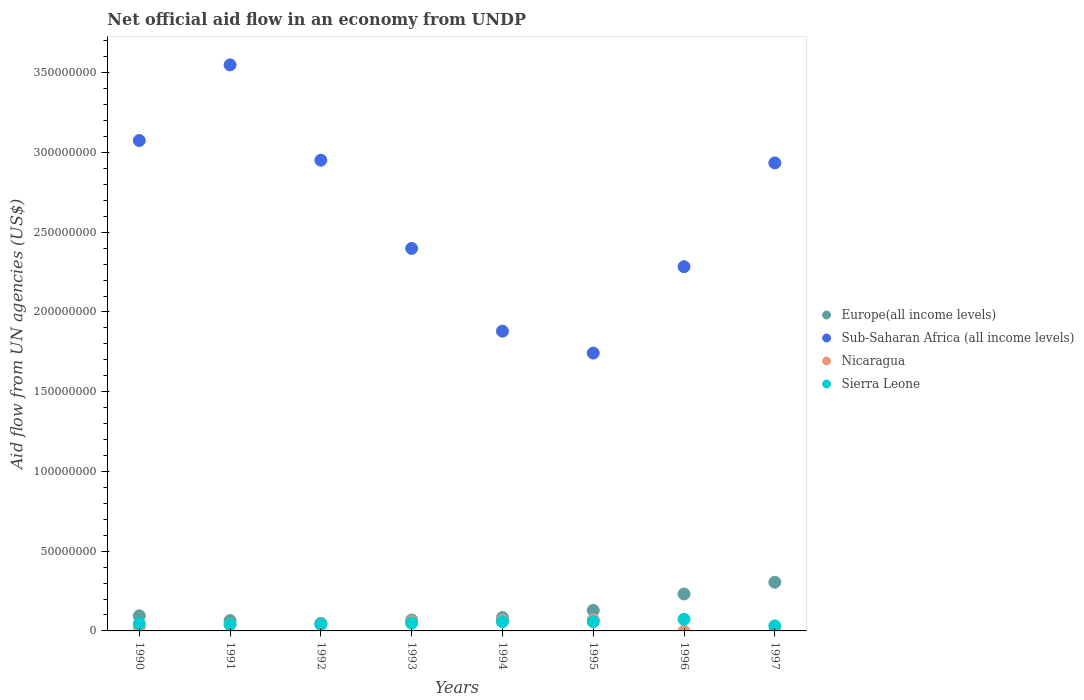Is the number of dotlines equal to the number of legend labels?
Keep it short and to the point. No. What is the net official aid flow in Europe(all income levels) in 1993?
Offer a very short reply. 6.83e+06. Across all years, what is the maximum net official aid flow in Sub-Saharan Africa (all income levels)?
Make the answer very short. 3.55e+08. Across all years, what is the minimum net official aid flow in Europe(all income levels)?
Make the answer very short. 4.74e+06. What is the total net official aid flow in Nicaragua in the graph?
Ensure brevity in your answer.  3.03e+07. What is the difference between the net official aid flow in Sub-Saharan Africa (all income levels) in 1990 and that in 1996?
Provide a short and direct response. 7.91e+07. What is the difference between the net official aid flow in Nicaragua in 1992 and the net official aid flow in Sub-Saharan Africa (all income levels) in 1990?
Keep it short and to the point. -3.03e+08. What is the average net official aid flow in Europe(all income levels) per year?
Offer a very short reply. 1.28e+07. In the year 1993, what is the difference between the net official aid flow in Europe(all income levels) and net official aid flow in Nicaragua?
Provide a succinct answer. 1.08e+06. In how many years, is the net official aid flow in Europe(all income levels) greater than 290000000 US$?
Ensure brevity in your answer.  0. What is the ratio of the net official aid flow in Nicaragua in 1990 to that in 1995?
Your answer should be very brief. 0.33. Is the net official aid flow in Sierra Leone in 1994 less than that in 1996?
Your answer should be compact. Yes. Is the difference between the net official aid flow in Europe(all income levels) in 1991 and 1993 greater than the difference between the net official aid flow in Nicaragua in 1991 and 1993?
Offer a terse response. Yes. What is the difference between the highest and the second highest net official aid flow in Sub-Saharan Africa (all income levels)?
Make the answer very short. 4.74e+07. What is the difference between the highest and the lowest net official aid flow in Sub-Saharan Africa (all income levels)?
Provide a succinct answer. 1.81e+08. Is it the case that in every year, the sum of the net official aid flow in Nicaragua and net official aid flow in Sierra Leone  is greater than the net official aid flow in Europe(all income levels)?
Your answer should be very brief. No. Is the net official aid flow in Sierra Leone strictly less than the net official aid flow in Europe(all income levels) over the years?
Ensure brevity in your answer.  Yes. How many years are there in the graph?
Provide a short and direct response. 8. How many legend labels are there?
Offer a very short reply. 4. What is the title of the graph?
Your answer should be compact. Net official aid flow in an economy from UNDP. Does "Egypt, Arab Rep." appear as one of the legend labels in the graph?
Ensure brevity in your answer.  No. What is the label or title of the Y-axis?
Your answer should be very brief. Aid flow from UN agencies (US$). What is the Aid flow from UN agencies (US$) in Europe(all income levels) in 1990?
Give a very brief answer. 9.47e+06. What is the Aid flow from UN agencies (US$) in Sub-Saharan Africa (all income levels) in 1990?
Give a very brief answer. 3.08e+08. What is the Aid flow from UN agencies (US$) in Nicaragua in 1990?
Your answer should be compact. 2.34e+06. What is the Aid flow from UN agencies (US$) in Sierra Leone in 1990?
Ensure brevity in your answer.  4.57e+06. What is the Aid flow from UN agencies (US$) of Europe(all income levels) in 1991?
Make the answer very short. 6.49e+06. What is the Aid flow from UN agencies (US$) of Sub-Saharan Africa (all income levels) in 1991?
Provide a short and direct response. 3.55e+08. What is the Aid flow from UN agencies (US$) in Nicaragua in 1991?
Provide a succinct answer. 4.14e+06. What is the Aid flow from UN agencies (US$) in Sierra Leone in 1991?
Make the answer very short. 4.04e+06. What is the Aid flow from UN agencies (US$) in Europe(all income levels) in 1992?
Provide a short and direct response. 4.74e+06. What is the Aid flow from UN agencies (US$) in Sub-Saharan Africa (all income levels) in 1992?
Offer a terse response. 2.95e+08. What is the Aid flow from UN agencies (US$) of Nicaragua in 1992?
Your answer should be very brief. 4.34e+06. What is the Aid flow from UN agencies (US$) of Sierra Leone in 1992?
Provide a short and direct response. 4.11e+06. What is the Aid flow from UN agencies (US$) in Europe(all income levels) in 1993?
Make the answer very short. 6.83e+06. What is the Aid flow from UN agencies (US$) of Sub-Saharan Africa (all income levels) in 1993?
Offer a very short reply. 2.40e+08. What is the Aid flow from UN agencies (US$) of Nicaragua in 1993?
Make the answer very short. 5.75e+06. What is the Aid flow from UN agencies (US$) of Sierra Leone in 1993?
Offer a very short reply. 4.93e+06. What is the Aid flow from UN agencies (US$) of Europe(all income levels) in 1994?
Make the answer very short. 8.38e+06. What is the Aid flow from UN agencies (US$) of Sub-Saharan Africa (all income levels) in 1994?
Ensure brevity in your answer.  1.88e+08. What is the Aid flow from UN agencies (US$) in Nicaragua in 1994?
Offer a terse response. 6.73e+06. What is the Aid flow from UN agencies (US$) in Sierra Leone in 1994?
Give a very brief answer. 5.75e+06. What is the Aid flow from UN agencies (US$) in Europe(all income levels) in 1995?
Give a very brief answer. 1.29e+07. What is the Aid flow from UN agencies (US$) in Sub-Saharan Africa (all income levels) in 1995?
Keep it short and to the point. 1.74e+08. What is the Aid flow from UN agencies (US$) of Nicaragua in 1995?
Offer a terse response. 7.02e+06. What is the Aid flow from UN agencies (US$) of Sierra Leone in 1995?
Keep it short and to the point. 5.78e+06. What is the Aid flow from UN agencies (US$) in Europe(all income levels) in 1996?
Your answer should be very brief. 2.32e+07. What is the Aid flow from UN agencies (US$) of Sub-Saharan Africa (all income levels) in 1996?
Offer a very short reply. 2.28e+08. What is the Aid flow from UN agencies (US$) of Sierra Leone in 1996?
Offer a very short reply. 7.28e+06. What is the Aid flow from UN agencies (US$) of Europe(all income levels) in 1997?
Your response must be concise. 3.05e+07. What is the Aid flow from UN agencies (US$) in Sub-Saharan Africa (all income levels) in 1997?
Your response must be concise. 2.93e+08. What is the Aid flow from UN agencies (US$) in Sierra Leone in 1997?
Offer a very short reply. 3.15e+06. Across all years, what is the maximum Aid flow from UN agencies (US$) in Europe(all income levels)?
Keep it short and to the point. 3.05e+07. Across all years, what is the maximum Aid flow from UN agencies (US$) of Sub-Saharan Africa (all income levels)?
Your response must be concise. 3.55e+08. Across all years, what is the maximum Aid flow from UN agencies (US$) in Nicaragua?
Your response must be concise. 7.02e+06. Across all years, what is the maximum Aid flow from UN agencies (US$) of Sierra Leone?
Keep it short and to the point. 7.28e+06. Across all years, what is the minimum Aid flow from UN agencies (US$) in Europe(all income levels)?
Your response must be concise. 4.74e+06. Across all years, what is the minimum Aid flow from UN agencies (US$) of Sub-Saharan Africa (all income levels)?
Your response must be concise. 1.74e+08. Across all years, what is the minimum Aid flow from UN agencies (US$) in Sierra Leone?
Offer a very short reply. 3.15e+06. What is the total Aid flow from UN agencies (US$) in Europe(all income levels) in the graph?
Keep it short and to the point. 1.02e+08. What is the total Aid flow from UN agencies (US$) in Sub-Saharan Africa (all income levels) in the graph?
Provide a succinct answer. 2.08e+09. What is the total Aid flow from UN agencies (US$) in Nicaragua in the graph?
Give a very brief answer. 3.03e+07. What is the total Aid flow from UN agencies (US$) of Sierra Leone in the graph?
Give a very brief answer. 3.96e+07. What is the difference between the Aid flow from UN agencies (US$) in Europe(all income levels) in 1990 and that in 1991?
Offer a terse response. 2.98e+06. What is the difference between the Aid flow from UN agencies (US$) in Sub-Saharan Africa (all income levels) in 1990 and that in 1991?
Give a very brief answer. -4.74e+07. What is the difference between the Aid flow from UN agencies (US$) of Nicaragua in 1990 and that in 1991?
Your answer should be very brief. -1.80e+06. What is the difference between the Aid flow from UN agencies (US$) of Sierra Leone in 1990 and that in 1991?
Give a very brief answer. 5.30e+05. What is the difference between the Aid flow from UN agencies (US$) in Europe(all income levels) in 1990 and that in 1992?
Give a very brief answer. 4.73e+06. What is the difference between the Aid flow from UN agencies (US$) of Sub-Saharan Africa (all income levels) in 1990 and that in 1992?
Offer a terse response. 1.24e+07. What is the difference between the Aid flow from UN agencies (US$) of Sierra Leone in 1990 and that in 1992?
Provide a succinct answer. 4.60e+05. What is the difference between the Aid flow from UN agencies (US$) of Europe(all income levels) in 1990 and that in 1993?
Your answer should be compact. 2.64e+06. What is the difference between the Aid flow from UN agencies (US$) in Sub-Saharan Africa (all income levels) in 1990 and that in 1993?
Your response must be concise. 6.77e+07. What is the difference between the Aid flow from UN agencies (US$) in Nicaragua in 1990 and that in 1993?
Provide a succinct answer. -3.41e+06. What is the difference between the Aid flow from UN agencies (US$) in Sierra Leone in 1990 and that in 1993?
Give a very brief answer. -3.60e+05. What is the difference between the Aid flow from UN agencies (US$) in Europe(all income levels) in 1990 and that in 1994?
Provide a succinct answer. 1.09e+06. What is the difference between the Aid flow from UN agencies (US$) of Sub-Saharan Africa (all income levels) in 1990 and that in 1994?
Provide a succinct answer. 1.20e+08. What is the difference between the Aid flow from UN agencies (US$) in Nicaragua in 1990 and that in 1994?
Ensure brevity in your answer.  -4.39e+06. What is the difference between the Aid flow from UN agencies (US$) in Sierra Leone in 1990 and that in 1994?
Your answer should be compact. -1.18e+06. What is the difference between the Aid flow from UN agencies (US$) in Europe(all income levels) in 1990 and that in 1995?
Offer a terse response. -3.42e+06. What is the difference between the Aid flow from UN agencies (US$) in Sub-Saharan Africa (all income levels) in 1990 and that in 1995?
Give a very brief answer. 1.33e+08. What is the difference between the Aid flow from UN agencies (US$) of Nicaragua in 1990 and that in 1995?
Offer a very short reply. -4.68e+06. What is the difference between the Aid flow from UN agencies (US$) of Sierra Leone in 1990 and that in 1995?
Offer a very short reply. -1.21e+06. What is the difference between the Aid flow from UN agencies (US$) in Europe(all income levels) in 1990 and that in 1996?
Make the answer very short. -1.37e+07. What is the difference between the Aid flow from UN agencies (US$) in Sub-Saharan Africa (all income levels) in 1990 and that in 1996?
Offer a very short reply. 7.91e+07. What is the difference between the Aid flow from UN agencies (US$) of Sierra Leone in 1990 and that in 1996?
Ensure brevity in your answer.  -2.71e+06. What is the difference between the Aid flow from UN agencies (US$) of Europe(all income levels) in 1990 and that in 1997?
Your response must be concise. -2.10e+07. What is the difference between the Aid flow from UN agencies (US$) in Sub-Saharan Africa (all income levels) in 1990 and that in 1997?
Provide a succinct answer. 1.40e+07. What is the difference between the Aid flow from UN agencies (US$) in Sierra Leone in 1990 and that in 1997?
Offer a very short reply. 1.42e+06. What is the difference between the Aid flow from UN agencies (US$) of Europe(all income levels) in 1991 and that in 1992?
Your response must be concise. 1.75e+06. What is the difference between the Aid flow from UN agencies (US$) in Sub-Saharan Africa (all income levels) in 1991 and that in 1992?
Make the answer very short. 5.98e+07. What is the difference between the Aid flow from UN agencies (US$) of Sierra Leone in 1991 and that in 1992?
Offer a terse response. -7.00e+04. What is the difference between the Aid flow from UN agencies (US$) of Europe(all income levels) in 1991 and that in 1993?
Your answer should be compact. -3.40e+05. What is the difference between the Aid flow from UN agencies (US$) in Sub-Saharan Africa (all income levels) in 1991 and that in 1993?
Offer a very short reply. 1.15e+08. What is the difference between the Aid flow from UN agencies (US$) of Nicaragua in 1991 and that in 1993?
Give a very brief answer. -1.61e+06. What is the difference between the Aid flow from UN agencies (US$) of Sierra Leone in 1991 and that in 1993?
Your answer should be compact. -8.90e+05. What is the difference between the Aid flow from UN agencies (US$) of Europe(all income levels) in 1991 and that in 1994?
Give a very brief answer. -1.89e+06. What is the difference between the Aid flow from UN agencies (US$) of Sub-Saharan Africa (all income levels) in 1991 and that in 1994?
Give a very brief answer. 1.67e+08. What is the difference between the Aid flow from UN agencies (US$) of Nicaragua in 1991 and that in 1994?
Offer a terse response. -2.59e+06. What is the difference between the Aid flow from UN agencies (US$) in Sierra Leone in 1991 and that in 1994?
Your response must be concise. -1.71e+06. What is the difference between the Aid flow from UN agencies (US$) in Europe(all income levels) in 1991 and that in 1995?
Provide a short and direct response. -6.40e+06. What is the difference between the Aid flow from UN agencies (US$) of Sub-Saharan Africa (all income levels) in 1991 and that in 1995?
Offer a very short reply. 1.81e+08. What is the difference between the Aid flow from UN agencies (US$) in Nicaragua in 1991 and that in 1995?
Keep it short and to the point. -2.88e+06. What is the difference between the Aid flow from UN agencies (US$) in Sierra Leone in 1991 and that in 1995?
Keep it short and to the point. -1.74e+06. What is the difference between the Aid flow from UN agencies (US$) of Europe(all income levels) in 1991 and that in 1996?
Keep it short and to the point. -1.67e+07. What is the difference between the Aid flow from UN agencies (US$) of Sub-Saharan Africa (all income levels) in 1991 and that in 1996?
Provide a short and direct response. 1.27e+08. What is the difference between the Aid flow from UN agencies (US$) of Sierra Leone in 1991 and that in 1996?
Keep it short and to the point. -3.24e+06. What is the difference between the Aid flow from UN agencies (US$) in Europe(all income levels) in 1991 and that in 1997?
Give a very brief answer. -2.40e+07. What is the difference between the Aid flow from UN agencies (US$) in Sub-Saharan Africa (all income levels) in 1991 and that in 1997?
Your answer should be compact. 6.15e+07. What is the difference between the Aid flow from UN agencies (US$) in Sierra Leone in 1991 and that in 1997?
Offer a terse response. 8.90e+05. What is the difference between the Aid flow from UN agencies (US$) of Europe(all income levels) in 1992 and that in 1993?
Your answer should be compact. -2.09e+06. What is the difference between the Aid flow from UN agencies (US$) of Sub-Saharan Africa (all income levels) in 1992 and that in 1993?
Your answer should be compact. 5.53e+07. What is the difference between the Aid flow from UN agencies (US$) of Nicaragua in 1992 and that in 1993?
Your answer should be very brief. -1.41e+06. What is the difference between the Aid flow from UN agencies (US$) of Sierra Leone in 1992 and that in 1993?
Your answer should be compact. -8.20e+05. What is the difference between the Aid flow from UN agencies (US$) in Europe(all income levels) in 1992 and that in 1994?
Keep it short and to the point. -3.64e+06. What is the difference between the Aid flow from UN agencies (US$) of Sub-Saharan Africa (all income levels) in 1992 and that in 1994?
Offer a terse response. 1.07e+08. What is the difference between the Aid flow from UN agencies (US$) of Nicaragua in 1992 and that in 1994?
Give a very brief answer. -2.39e+06. What is the difference between the Aid flow from UN agencies (US$) of Sierra Leone in 1992 and that in 1994?
Give a very brief answer. -1.64e+06. What is the difference between the Aid flow from UN agencies (US$) in Europe(all income levels) in 1992 and that in 1995?
Your answer should be very brief. -8.15e+06. What is the difference between the Aid flow from UN agencies (US$) of Sub-Saharan Africa (all income levels) in 1992 and that in 1995?
Provide a succinct answer. 1.21e+08. What is the difference between the Aid flow from UN agencies (US$) in Nicaragua in 1992 and that in 1995?
Give a very brief answer. -2.68e+06. What is the difference between the Aid flow from UN agencies (US$) of Sierra Leone in 1992 and that in 1995?
Your answer should be compact. -1.67e+06. What is the difference between the Aid flow from UN agencies (US$) of Europe(all income levels) in 1992 and that in 1996?
Make the answer very short. -1.84e+07. What is the difference between the Aid flow from UN agencies (US$) in Sub-Saharan Africa (all income levels) in 1992 and that in 1996?
Your answer should be very brief. 6.68e+07. What is the difference between the Aid flow from UN agencies (US$) of Sierra Leone in 1992 and that in 1996?
Provide a short and direct response. -3.17e+06. What is the difference between the Aid flow from UN agencies (US$) of Europe(all income levels) in 1992 and that in 1997?
Your answer should be very brief. -2.58e+07. What is the difference between the Aid flow from UN agencies (US$) of Sub-Saharan Africa (all income levels) in 1992 and that in 1997?
Provide a short and direct response. 1.69e+06. What is the difference between the Aid flow from UN agencies (US$) of Sierra Leone in 1992 and that in 1997?
Offer a terse response. 9.60e+05. What is the difference between the Aid flow from UN agencies (US$) in Europe(all income levels) in 1993 and that in 1994?
Offer a terse response. -1.55e+06. What is the difference between the Aid flow from UN agencies (US$) of Sub-Saharan Africa (all income levels) in 1993 and that in 1994?
Make the answer very short. 5.19e+07. What is the difference between the Aid flow from UN agencies (US$) of Nicaragua in 1993 and that in 1994?
Your response must be concise. -9.80e+05. What is the difference between the Aid flow from UN agencies (US$) in Sierra Leone in 1993 and that in 1994?
Offer a terse response. -8.20e+05. What is the difference between the Aid flow from UN agencies (US$) of Europe(all income levels) in 1993 and that in 1995?
Ensure brevity in your answer.  -6.06e+06. What is the difference between the Aid flow from UN agencies (US$) in Sub-Saharan Africa (all income levels) in 1993 and that in 1995?
Your response must be concise. 6.56e+07. What is the difference between the Aid flow from UN agencies (US$) in Nicaragua in 1993 and that in 1995?
Provide a succinct answer. -1.27e+06. What is the difference between the Aid flow from UN agencies (US$) in Sierra Leone in 1993 and that in 1995?
Your answer should be compact. -8.50e+05. What is the difference between the Aid flow from UN agencies (US$) in Europe(all income levels) in 1993 and that in 1996?
Ensure brevity in your answer.  -1.63e+07. What is the difference between the Aid flow from UN agencies (US$) in Sub-Saharan Africa (all income levels) in 1993 and that in 1996?
Your response must be concise. 1.14e+07. What is the difference between the Aid flow from UN agencies (US$) of Sierra Leone in 1993 and that in 1996?
Your answer should be compact. -2.35e+06. What is the difference between the Aid flow from UN agencies (US$) of Europe(all income levels) in 1993 and that in 1997?
Offer a very short reply. -2.37e+07. What is the difference between the Aid flow from UN agencies (US$) in Sub-Saharan Africa (all income levels) in 1993 and that in 1997?
Give a very brief answer. -5.36e+07. What is the difference between the Aid flow from UN agencies (US$) of Sierra Leone in 1993 and that in 1997?
Offer a terse response. 1.78e+06. What is the difference between the Aid flow from UN agencies (US$) of Europe(all income levels) in 1994 and that in 1995?
Provide a short and direct response. -4.51e+06. What is the difference between the Aid flow from UN agencies (US$) of Sub-Saharan Africa (all income levels) in 1994 and that in 1995?
Your answer should be compact. 1.37e+07. What is the difference between the Aid flow from UN agencies (US$) in Nicaragua in 1994 and that in 1995?
Your answer should be compact. -2.90e+05. What is the difference between the Aid flow from UN agencies (US$) in Europe(all income levels) in 1994 and that in 1996?
Offer a very short reply. -1.48e+07. What is the difference between the Aid flow from UN agencies (US$) in Sub-Saharan Africa (all income levels) in 1994 and that in 1996?
Make the answer very short. -4.04e+07. What is the difference between the Aid flow from UN agencies (US$) of Sierra Leone in 1994 and that in 1996?
Make the answer very short. -1.53e+06. What is the difference between the Aid flow from UN agencies (US$) in Europe(all income levels) in 1994 and that in 1997?
Ensure brevity in your answer.  -2.21e+07. What is the difference between the Aid flow from UN agencies (US$) of Sub-Saharan Africa (all income levels) in 1994 and that in 1997?
Make the answer very short. -1.06e+08. What is the difference between the Aid flow from UN agencies (US$) of Sierra Leone in 1994 and that in 1997?
Provide a short and direct response. 2.60e+06. What is the difference between the Aid flow from UN agencies (US$) in Europe(all income levels) in 1995 and that in 1996?
Make the answer very short. -1.03e+07. What is the difference between the Aid flow from UN agencies (US$) of Sub-Saharan Africa (all income levels) in 1995 and that in 1996?
Your answer should be compact. -5.42e+07. What is the difference between the Aid flow from UN agencies (US$) in Sierra Leone in 1995 and that in 1996?
Provide a short and direct response. -1.50e+06. What is the difference between the Aid flow from UN agencies (US$) of Europe(all income levels) in 1995 and that in 1997?
Give a very brief answer. -1.76e+07. What is the difference between the Aid flow from UN agencies (US$) in Sub-Saharan Africa (all income levels) in 1995 and that in 1997?
Ensure brevity in your answer.  -1.19e+08. What is the difference between the Aid flow from UN agencies (US$) in Sierra Leone in 1995 and that in 1997?
Your response must be concise. 2.63e+06. What is the difference between the Aid flow from UN agencies (US$) of Europe(all income levels) in 1996 and that in 1997?
Offer a terse response. -7.35e+06. What is the difference between the Aid flow from UN agencies (US$) of Sub-Saharan Africa (all income levels) in 1996 and that in 1997?
Offer a very short reply. -6.51e+07. What is the difference between the Aid flow from UN agencies (US$) in Sierra Leone in 1996 and that in 1997?
Keep it short and to the point. 4.13e+06. What is the difference between the Aid flow from UN agencies (US$) of Europe(all income levels) in 1990 and the Aid flow from UN agencies (US$) of Sub-Saharan Africa (all income levels) in 1991?
Give a very brief answer. -3.45e+08. What is the difference between the Aid flow from UN agencies (US$) of Europe(all income levels) in 1990 and the Aid flow from UN agencies (US$) of Nicaragua in 1991?
Your answer should be compact. 5.33e+06. What is the difference between the Aid flow from UN agencies (US$) of Europe(all income levels) in 1990 and the Aid flow from UN agencies (US$) of Sierra Leone in 1991?
Provide a short and direct response. 5.43e+06. What is the difference between the Aid flow from UN agencies (US$) of Sub-Saharan Africa (all income levels) in 1990 and the Aid flow from UN agencies (US$) of Nicaragua in 1991?
Offer a very short reply. 3.03e+08. What is the difference between the Aid flow from UN agencies (US$) of Sub-Saharan Africa (all income levels) in 1990 and the Aid flow from UN agencies (US$) of Sierra Leone in 1991?
Ensure brevity in your answer.  3.03e+08. What is the difference between the Aid flow from UN agencies (US$) in Nicaragua in 1990 and the Aid flow from UN agencies (US$) in Sierra Leone in 1991?
Give a very brief answer. -1.70e+06. What is the difference between the Aid flow from UN agencies (US$) in Europe(all income levels) in 1990 and the Aid flow from UN agencies (US$) in Sub-Saharan Africa (all income levels) in 1992?
Give a very brief answer. -2.86e+08. What is the difference between the Aid flow from UN agencies (US$) in Europe(all income levels) in 1990 and the Aid flow from UN agencies (US$) in Nicaragua in 1992?
Ensure brevity in your answer.  5.13e+06. What is the difference between the Aid flow from UN agencies (US$) in Europe(all income levels) in 1990 and the Aid flow from UN agencies (US$) in Sierra Leone in 1992?
Provide a short and direct response. 5.36e+06. What is the difference between the Aid flow from UN agencies (US$) in Sub-Saharan Africa (all income levels) in 1990 and the Aid flow from UN agencies (US$) in Nicaragua in 1992?
Keep it short and to the point. 3.03e+08. What is the difference between the Aid flow from UN agencies (US$) of Sub-Saharan Africa (all income levels) in 1990 and the Aid flow from UN agencies (US$) of Sierra Leone in 1992?
Your answer should be compact. 3.03e+08. What is the difference between the Aid flow from UN agencies (US$) of Nicaragua in 1990 and the Aid flow from UN agencies (US$) of Sierra Leone in 1992?
Your response must be concise. -1.77e+06. What is the difference between the Aid flow from UN agencies (US$) in Europe(all income levels) in 1990 and the Aid flow from UN agencies (US$) in Sub-Saharan Africa (all income levels) in 1993?
Ensure brevity in your answer.  -2.30e+08. What is the difference between the Aid flow from UN agencies (US$) in Europe(all income levels) in 1990 and the Aid flow from UN agencies (US$) in Nicaragua in 1993?
Keep it short and to the point. 3.72e+06. What is the difference between the Aid flow from UN agencies (US$) in Europe(all income levels) in 1990 and the Aid flow from UN agencies (US$) in Sierra Leone in 1993?
Provide a short and direct response. 4.54e+06. What is the difference between the Aid flow from UN agencies (US$) of Sub-Saharan Africa (all income levels) in 1990 and the Aid flow from UN agencies (US$) of Nicaragua in 1993?
Ensure brevity in your answer.  3.02e+08. What is the difference between the Aid flow from UN agencies (US$) of Sub-Saharan Africa (all income levels) in 1990 and the Aid flow from UN agencies (US$) of Sierra Leone in 1993?
Your response must be concise. 3.03e+08. What is the difference between the Aid flow from UN agencies (US$) of Nicaragua in 1990 and the Aid flow from UN agencies (US$) of Sierra Leone in 1993?
Your response must be concise. -2.59e+06. What is the difference between the Aid flow from UN agencies (US$) in Europe(all income levels) in 1990 and the Aid flow from UN agencies (US$) in Sub-Saharan Africa (all income levels) in 1994?
Your answer should be very brief. -1.78e+08. What is the difference between the Aid flow from UN agencies (US$) in Europe(all income levels) in 1990 and the Aid flow from UN agencies (US$) in Nicaragua in 1994?
Provide a succinct answer. 2.74e+06. What is the difference between the Aid flow from UN agencies (US$) of Europe(all income levels) in 1990 and the Aid flow from UN agencies (US$) of Sierra Leone in 1994?
Offer a very short reply. 3.72e+06. What is the difference between the Aid flow from UN agencies (US$) in Sub-Saharan Africa (all income levels) in 1990 and the Aid flow from UN agencies (US$) in Nicaragua in 1994?
Keep it short and to the point. 3.01e+08. What is the difference between the Aid flow from UN agencies (US$) of Sub-Saharan Africa (all income levels) in 1990 and the Aid flow from UN agencies (US$) of Sierra Leone in 1994?
Your response must be concise. 3.02e+08. What is the difference between the Aid flow from UN agencies (US$) in Nicaragua in 1990 and the Aid flow from UN agencies (US$) in Sierra Leone in 1994?
Keep it short and to the point. -3.41e+06. What is the difference between the Aid flow from UN agencies (US$) of Europe(all income levels) in 1990 and the Aid flow from UN agencies (US$) of Sub-Saharan Africa (all income levels) in 1995?
Keep it short and to the point. -1.65e+08. What is the difference between the Aid flow from UN agencies (US$) in Europe(all income levels) in 1990 and the Aid flow from UN agencies (US$) in Nicaragua in 1995?
Ensure brevity in your answer.  2.45e+06. What is the difference between the Aid flow from UN agencies (US$) in Europe(all income levels) in 1990 and the Aid flow from UN agencies (US$) in Sierra Leone in 1995?
Provide a short and direct response. 3.69e+06. What is the difference between the Aid flow from UN agencies (US$) of Sub-Saharan Africa (all income levels) in 1990 and the Aid flow from UN agencies (US$) of Nicaragua in 1995?
Your response must be concise. 3.00e+08. What is the difference between the Aid flow from UN agencies (US$) of Sub-Saharan Africa (all income levels) in 1990 and the Aid flow from UN agencies (US$) of Sierra Leone in 1995?
Provide a short and direct response. 3.02e+08. What is the difference between the Aid flow from UN agencies (US$) of Nicaragua in 1990 and the Aid flow from UN agencies (US$) of Sierra Leone in 1995?
Your answer should be compact. -3.44e+06. What is the difference between the Aid flow from UN agencies (US$) in Europe(all income levels) in 1990 and the Aid flow from UN agencies (US$) in Sub-Saharan Africa (all income levels) in 1996?
Provide a short and direct response. -2.19e+08. What is the difference between the Aid flow from UN agencies (US$) in Europe(all income levels) in 1990 and the Aid flow from UN agencies (US$) in Sierra Leone in 1996?
Your answer should be very brief. 2.19e+06. What is the difference between the Aid flow from UN agencies (US$) in Sub-Saharan Africa (all income levels) in 1990 and the Aid flow from UN agencies (US$) in Sierra Leone in 1996?
Ensure brevity in your answer.  3.00e+08. What is the difference between the Aid flow from UN agencies (US$) in Nicaragua in 1990 and the Aid flow from UN agencies (US$) in Sierra Leone in 1996?
Keep it short and to the point. -4.94e+06. What is the difference between the Aid flow from UN agencies (US$) in Europe(all income levels) in 1990 and the Aid flow from UN agencies (US$) in Sub-Saharan Africa (all income levels) in 1997?
Provide a short and direct response. -2.84e+08. What is the difference between the Aid flow from UN agencies (US$) in Europe(all income levels) in 1990 and the Aid flow from UN agencies (US$) in Sierra Leone in 1997?
Your answer should be compact. 6.32e+06. What is the difference between the Aid flow from UN agencies (US$) of Sub-Saharan Africa (all income levels) in 1990 and the Aid flow from UN agencies (US$) of Sierra Leone in 1997?
Keep it short and to the point. 3.04e+08. What is the difference between the Aid flow from UN agencies (US$) in Nicaragua in 1990 and the Aid flow from UN agencies (US$) in Sierra Leone in 1997?
Offer a terse response. -8.10e+05. What is the difference between the Aid flow from UN agencies (US$) in Europe(all income levels) in 1991 and the Aid flow from UN agencies (US$) in Sub-Saharan Africa (all income levels) in 1992?
Offer a very short reply. -2.89e+08. What is the difference between the Aid flow from UN agencies (US$) in Europe(all income levels) in 1991 and the Aid flow from UN agencies (US$) in Nicaragua in 1992?
Provide a succinct answer. 2.15e+06. What is the difference between the Aid flow from UN agencies (US$) of Europe(all income levels) in 1991 and the Aid flow from UN agencies (US$) of Sierra Leone in 1992?
Offer a terse response. 2.38e+06. What is the difference between the Aid flow from UN agencies (US$) of Sub-Saharan Africa (all income levels) in 1991 and the Aid flow from UN agencies (US$) of Nicaragua in 1992?
Provide a short and direct response. 3.51e+08. What is the difference between the Aid flow from UN agencies (US$) in Sub-Saharan Africa (all income levels) in 1991 and the Aid flow from UN agencies (US$) in Sierra Leone in 1992?
Offer a very short reply. 3.51e+08. What is the difference between the Aid flow from UN agencies (US$) in Nicaragua in 1991 and the Aid flow from UN agencies (US$) in Sierra Leone in 1992?
Ensure brevity in your answer.  3.00e+04. What is the difference between the Aid flow from UN agencies (US$) in Europe(all income levels) in 1991 and the Aid flow from UN agencies (US$) in Sub-Saharan Africa (all income levels) in 1993?
Your answer should be very brief. -2.33e+08. What is the difference between the Aid flow from UN agencies (US$) of Europe(all income levels) in 1991 and the Aid flow from UN agencies (US$) of Nicaragua in 1993?
Make the answer very short. 7.40e+05. What is the difference between the Aid flow from UN agencies (US$) of Europe(all income levels) in 1991 and the Aid flow from UN agencies (US$) of Sierra Leone in 1993?
Make the answer very short. 1.56e+06. What is the difference between the Aid flow from UN agencies (US$) in Sub-Saharan Africa (all income levels) in 1991 and the Aid flow from UN agencies (US$) in Nicaragua in 1993?
Your response must be concise. 3.49e+08. What is the difference between the Aid flow from UN agencies (US$) of Sub-Saharan Africa (all income levels) in 1991 and the Aid flow from UN agencies (US$) of Sierra Leone in 1993?
Ensure brevity in your answer.  3.50e+08. What is the difference between the Aid flow from UN agencies (US$) in Nicaragua in 1991 and the Aid flow from UN agencies (US$) in Sierra Leone in 1993?
Provide a succinct answer. -7.90e+05. What is the difference between the Aid flow from UN agencies (US$) of Europe(all income levels) in 1991 and the Aid flow from UN agencies (US$) of Sub-Saharan Africa (all income levels) in 1994?
Your answer should be very brief. -1.81e+08. What is the difference between the Aid flow from UN agencies (US$) of Europe(all income levels) in 1991 and the Aid flow from UN agencies (US$) of Nicaragua in 1994?
Your response must be concise. -2.40e+05. What is the difference between the Aid flow from UN agencies (US$) in Europe(all income levels) in 1991 and the Aid flow from UN agencies (US$) in Sierra Leone in 1994?
Your response must be concise. 7.40e+05. What is the difference between the Aid flow from UN agencies (US$) of Sub-Saharan Africa (all income levels) in 1991 and the Aid flow from UN agencies (US$) of Nicaragua in 1994?
Provide a short and direct response. 3.48e+08. What is the difference between the Aid flow from UN agencies (US$) in Sub-Saharan Africa (all income levels) in 1991 and the Aid flow from UN agencies (US$) in Sierra Leone in 1994?
Provide a short and direct response. 3.49e+08. What is the difference between the Aid flow from UN agencies (US$) in Nicaragua in 1991 and the Aid flow from UN agencies (US$) in Sierra Leone in 1994?
Keep it short and to the point. -1.61e+06. What is the difference between the Aid flow from UN agencies (US$) in Europe(all income levels) in 1991 and the Aid flow from UN agencies (US$) in Sub-Saharan Africa (all income levels) in 1995?
Make the answer very short. -1.68e+08. What is the difference between the Aid flow from UN agencies (US$) in Europe(all income levels) in 1991 and the Aid flow from UN agencies (US$) in Nicaragua in 1995?
Offer a terse response. -5.30e+05. What is the difference between the Aid flow from UN agencies (US$) in Europe(all income levels) in 1991 and the Aid flow from UN agencies (US$) in Sierra Leone in 1995?
Make the answer very short. 7.10e+05. What is the difference between the Aid flow from UN agencies (US$) in Sub-Saharan Africa (all income levels) in 1991 and the Aid flow from UN agencies (US$) in Nicaragua in 1995?
Make the answer very short. 3.48e+08. What is the difference between the Aid flow from UN agencies (US$) of Sub-Saharan Africa (all income levels) in 1991 and the Aid flow from UN agencies (US$) of Sierra Leone in 1995?
Provide a succinct answer. 3.49e+08. What is the difference between the Aid flow from UN agencies (US$) in Nicaragua in 1991 and the Aid flow from UN agencies (US$) in Sierra Leone in 1995?
Offer a very short reply. -1.64e+06. What is the difference between the Aid flow from UN agencies (US$) in Europe(all income levels) in 1991 and the Aid flow from UN agencies (US$) in Sub-Saharan Africa (all income levels) in 1996?
Offer a very short reply. -2.22e+08. What is the difference between the Aid flow from UN agencies (US$) of Europe(all income levels) in 1991 and the Aid flow from UN agencies (US$) of Sierra Leone in 1996?
Offer a very short reply. -7.90e+05. What is the difference between the Aid flow from UN agencies (US$) in Sub-Saharan Africa (all income levels) in 1991 and the Aid flow from UN agencies (US$) in Sierra Leone in 1996?
Provide a short and direct response. 3.48e+08. What is the difference between the Aid flow from UN agencies (US$) of Nicaragua in 1991 and the Aid flow from UN agencies (US$) of Sierra Leone in 1996?
Ensure brevity in your answer.  -3.14e+06. What is the difference between the Aid flow from UN agencies (US$) in Europe(all income levels) in 1991 and the Aid flow from UN agencies (US$) in Sub-Saharan Africa (all income levels) in 1997?
Your answer should be compact. -2.87e+08. What is the difference between the Aid flow from UN agencies (US$) in Europe(all income levels) in 1991 and the Aid flow from UN agencies (US$) in Sierra Leone in 1997?
Your response must be concise. 3.34e+06. What is the difference between the Aid flow from UN agencies (US$) of Sub-Saharan Africa (all income levels) in 1991 and the Aid flow from UN agencies (US$) of Sierra Leone in 1997?
Provide a short and direct response. 3.52e+08. What is the difference between the Aid flow from UN agencies (US$) in Nicaragua in 1991 and the Aid flow from UN agencies (US$) in Sierra Leone in 1997?
Your response must be concise. 9.90e+05. What is the difference between the Aid flow from UN agencies (US$) of Europe(all income levels) in 1992 and the Aid flow from UN agencies (US$) of Sub-Saharan Africa (all income levels) in 1993?
Give a very brief answer. -2.35e+08. What is the difference between the Aid flow from UN agencies (US$) in Europe(all income levels) in 1992 and the Aid flow from UN agencies (US$) in Nicaragua in 1993?
Provide a succinct answer. -1.01e+06. What is the difference between the Aid flow from UN agencies (US$) of Europe(all income levels) in 1992 and the Aid flow from UN agencies (US$) of Sierra Leone in 1993?
Your answer should be compact. -1.90e+05. What is the difference between the Aid flow from UN agencies (US$) of Sub-Saharan Africa (all income levels) in 1992 and the Aid flow from UN agencies (US$) of Nicaragua in 1993?
Keep it short and to the point. 2.89e+08. What is the difference between the Aid flow from UN agencies (US$) of Sub-Saharan Africa (all income levels) in 1992 and the Aid flow from UN agencies (US$) of Sierra Leone in 1993?
Your answer should be compact. 2.90e+08. What is the difference between the Aid flow from UN agencies (US$) in Nicaragua in 1992 and the Aid flow from UN agencies (US$) in Sierra Leone in 1993?
Provide a succinct answer. -5.90e+05. What is the difference between the Aid flow from UN agencies (US$) of Europe(all income levels) in 1992 and the Aid flow from UN agencies (US$) of Sub-Saharan Africa (all income levels) in 1994?
Keep it short and to the point. -1.83e+08. What is the difference between the Aid flow from UN agencies (US$) of Europe(all income levels) in 1992 and the Aid flow from UN agencies (US$) of Nicaragua in 1994?
Ensure brevity in your answer.  -1.99e+06. What is the difference between the Aid flow from UN agencies (US$) in Europe(all income levels) in 1992 and the Aid flow from UN agencies (US$) in Sierra Leone in 1994?
Ensure brevity in your answer.  -1.01e+06. What is the difference between the Aid flow from UN agencies (US$) of Sub-Saharan Africa (all income levels) in 1992 and the Aid flow from UN agencies (US$) of Nicaragua in 1994?
Your answer should be compact. 2.88e+08. What is the difference between the Aid flow from UN agencies (US$) in Sub-Saharan Africa (all income levels) in 1992 and the Aid flow from UN agencies (US$) in Sierra Leone in 1994?
Offer a very short reply. 2.89e+08. What is the difference between the Aid flow from UN agencies (US$) in Nicaragua in 1992 and the Aid flow from UN agencies (US$) in Sierra Leone in 1994?
Make the answer very short. -1.41e+06. What is the difference between the Aid flow from UN agencies (US$) of Europe(all income levels) in 1992 and the Aid flow from UN agencies (US$) of Sub-Saharan Africa (all income levels) in 1995?
Provide a succinct answer. -1.70e+08. What is the difference between the Aid flow from UN agencies (US$) of Europe(all income levels) in 1992 and the Aid flow from UN agencies (US$) of Nicaragua in 1995?
Give a very brief answer. -2.28e+06. What is the difference between the Aid flow from UN agencies (US$) in Europe(all income levels) in 1992 and the Aid flow from UN agencies (US$) in Sierra Leone in 1995?
Give a very brief answer. -1.04e+06. What is the difference between the Aid flow from UN agencies (US$) of Sub-Saharan Africa (all income levels) in 1992 and the Aid flow from UN agencies (US$) of Nicaragua in 1995?
Provide a short and direct response. 2.88e+08. What is the difference between the Aid flow from UN agencies (US$) of Sub-Saharan Africa (all income levels) in 1992 and the Aid flow from UN agencies (US$) of Sierra Leone in 1995?
Make the answer very short. 2.89e+08. What is the difference between the Aid flow from UN agencies (US$) in Nicaragua in 1992 and the Aid flow from UN agencies (US$) in Sierra Leone in 1995?
Your answer should be very brief. -1.44e+06. What is the difference between the Aid flow from UN agencies (US$) in Europe(all income levels) in 1992 and the Aid flow from UN agencies (US$) in Sub-Saharan Africa (all income levels) in 1996?
Give a very brief answer. -2.24e+08. What is the difference between the Aid flow from UN agencies (US$) of Europe(all income levels) in 1992 and the Aid flow from UN agencies (US$) of Sierra Leone in 1996?
Your answer should be compact. -2.54e+06. What is the difference between the Aid flow from UN agencies (US$) of Sub-Saharan Africa (all income levels) in 1992 and the Aid flow from UN agencies (US$) of Sierra Leone in 1996?
Your answer should be very brief. 2.88e+08. What is the difference between the Aid flow from UN agencies (US$) in Nicaragua in 1992 and the Aid flow from UN agencies (US$) in Sierra Leone in 1996?
Ensure brevity in your answer.  -2.94e+06. What is the difference between the Aid flow from UN agencies (US$) of Europe(all income levels) in 1992 and the Aid flow from UN agencies (US$) of Sub-Saharan Africa (all income levels) in 1997?
Your response must be concise. -2.89e+08. What is the difference between the Aid flow from UN agencies (US$) of Europe(all income levels) in 1992 and the Aid flow from UN agencies (US$) of Sierra Leone in 1997?
Offer a very short reply. 1.59e+06. What is the difference between the Aid flow from UN agencies (US$) in Sub-Saharan Africa (all income levels) in 1992 and the Aid flow from UN agencies (US$) in Sierra Leone in 1997?
Offer a very short reply. 2.92e+08. What is the difference between the Aid flow from UN agencies (US$) in Nicaragua in 1992 and the Aid flow from UN agencies (US$) in Sierra Leone in 1997?
Give a very brief answer. 1.19e+06. What is the difference between the Aid flow from UN agencies (US$) of Europe(all income levels) in 1993 and the Aid flow from UN agencies (US$) of Sub-Saharan Africa (all income levels) in 1994?
Make the answer very short. -1.81e+08. What is the difference between the Aid flow from UN agencies (US$) in Europe(all income levels) in 1993 and the Aid flow from UN agencies (US$) in Sierra Leone in 1994?
Provide a succinct answer. 1.08e+06. What is the difference between the Aid flow from UN agencies (US$) in Sub-Saharan Africa (all income levels) in 1993 and the Aid flow from UN agencies (US$) in Nicaragua in 1994?
Make the answer very short. 2.33e+08. What is the difference between the Aid flow from UN agencies (US$) in Sub-Saharan Africa (all income levels) in 1993 and the Aid flow from UN agencies (US$) in Sierra Leone in 1994?
Your answer should be compact. 2.34e+08. What is the difference between the Aid flow from UN agencies (US$) in Europe(all income levels) in 1993 and the Aid flow from UN agencies (US$) in Sub-Saharan Africa (all income levels) in 1995?
Offer a terse response. -1.67e+08. What is the difference between the Aid flow from UN agencies (US$) of Europe(all income levels) in 1993 and the Aid flow from UN agencies (US$) of Nicaragua in 1995?
Give a very brief answer. -1.90e+05. What is the difference between the Aid flow from UN agencies (US$) of Europe(all income levels) in 1993 and the Aid flow from UN agencies (US$) of Sierra Leone in 1995?
Offer a terse response. 1.05e+06. What is the difference between the Aid flow from UN agencies (US$) in Sub-Saharan Africa (all income levels) in 1993 and the Aid flow from UN agencies (US$) in Nicaragua in 1995?
Make the answer very short. 2.33e+08. What is the difference between the Aid flow from UN agencies (US$) in Sub-Saharan Africa (all income levels) in 1993 and the Aid flow from UN agencies (US$) in Sierra Leone in 1995?
Provide a succinct answer. 2.34e+08. What is the difference between the Aid flow from UN agencies (US$) of Europe(all income levels) in 1993 and the Aid flow from UN agencies (US$) of Sub-Saharan Africa (all income levels) in 1996?
Offer a terse response. -2.22e+08. What is the difference between the Aid flow from UN agencies (US$) in Europe(all income levels) in 1993 and the Aid flow from UN agencies (US$) in Sierra Leone in 1996?
Your response must be concise. -4.50e+05. What is the difference between the Aid flow from UN agencies (US$) of Sub-Saharan Africa (all income levels) in 1993 and the Aid flow from UN agencies (US$) of Sierra Leone in 1996?
Your response must be concise. 2.33e+08. What is the difference between the Aid flow from UN agencies (US$) in Nicaragua in 1993 and the Aid flow from UN agencies (US$) in Sierra Leone in 1996?
Provide a succinct answer. -1.53e+06. What is the difference between the Aid flow from UN agencies (US$) of Europe(all income levels) in 1993 and the Aid flow from UN agencies (US$) of Sub-Saharan Africa (all income levels) in 1997?
Your response must be concise. -2.87e+08. What is the difference between the Aid flow from UN agencies (US$) of Europe(all income levels) in 1993 and the Aid flow from UN agencies (US$) of Sierra Leone in 1997?
Offer a terse response. 3.68e+06. What is the difference between the Aid flow from UN agencies (US$) of Sub-Saharan Africa (all income levels) in 1993 and the Aid flow from UN agencies (US$) of Sierra Leone in 1997?
Provide a short and direct response. 2.37e+08. What is the difference between the Aid flow from UN agencies (US$) of Nicaragua in 1993 and the Aid flow from UN agencies (US$) of Sierra Leone in 1997?
Your answer should be very brief. 2.60e+06. What is the difference between the Aid flow from UN agencies (US$) in Europe(all income levels) in 1994 and the Aid flow from UN agencies (US$) in Sub-Saharan Africa (all income levels) in 1995?
Offer a very short reply. -1.66e+08. What is the difference between the Aid flow from UN agencies (US$) in Europe(all income levels) in 1994 and the Aid flow from UN agencies (US$) in Nicaragua in 1995?
Keep it short and to the point. 1.36e+06. What is the difference between the Aid flow from UN agencies (US$) in Europe(all income levels) in 1994 and the Aid flow from UN agencies (US$) in Sierra Leone in 1995?
Offer a very short reply. 2.60e+06. What is the difference between the Aid flow from UN agencies (US$) of Sub-Saharan Africa (all income levels) in 1994 and the Aid flow from UN agencies (US$) of Nicaragua in 1995?
Offer a terse response. 1.81e+08. What is the difference between the Aid flow from UN agencies (US$) in Sub-Saharan Africa (all income levels) in 1994 and the Aid flow from UN agencies (US$) in Sierra Leone in 1995?
Offer a terse response. 1.82e+08. What is the difference between the Aid flow from UN agencies (US$) in Nicaragua in 1994 and the Aid flow from UN agencies (US$) in Sierra Leone in 1995?
Offer a terse response. 9.50e+05. What is the difference between the Aid flow from UN agencies (US$) of Europe(all income levels) in 1994 and the Aid flow from UN agencies (US$) of Sub-Saharan Africa (all income levels) in 1996?
Offer a terse response. -2.20e+08. What is the difference between the Aid flow from UN agencies (US$) of Europe(all income levels) in 1994 and the Aid flow from UN agencies (US$) of Sierra Leone in 1996?
Make the answer very short. 1.10e+06. What is the difference between the Aid flow from UN agencies (US$) in Sub-Saharan Africa (all income levels) in 1994 and the Aid flow from UN agencies (US$) in Sierra Leone in 1996?
Provide a succinct answer. 1.81e+08. What is the difference between the Aid flow from UN agencies (US$) in Nicaragua in 1994 and the Aid flow from UN agencies (US$) in Sierra Leone in 1996?
Provide a succinct answer. -5.50e+05. What is the difference between the Aid flow from UN agencies (US$) in Europe(all income levels) in 1994 and the Aid flow from UN agencies (US$) in Sub-Saharan Africa (all income levels) in 1997?
Your response must be concise. -2.85e+08. What is the difference between the Aid flow from UN agencies (US$) in Europe(all income levels) in 1994 and the Aid flow from UN agencies (US$) in Sierra Leone in 1997?
Keep it short and to the point. 5.23e+06. What is the difference between the Aid flow from UN agencies (US$) of Sub-Saharan Africa (all income levels) in 1994 and the Aid flow from UN agencies (US$) of Sierra Leone in 1997?
Keep it short and to the point. 1.85e+08. What is the difference between the Aid flow from UN agencies (US$) of Nicaragua in 1994 and the Aid flow from UN agencies (US$) of Sierra Leone in 1997?
Your answer should be compact. 3.58e+06. What is the difference between the Aid flow from UN agencies (US$) in Europe(all income levels) in 1995 and the Aid flow from UN agencies (US$) in Sub-Saharan Africa (all income levels) in 1996?
Your response must be concise. -2.16e+08. What is the difference between the Aid flow from UN agencies (US$) of Europe(all income levels) in 1995 and the Aid flow from UN agencies (US$) of Sierra Leone in 1996?
Your response must be concise. 5.61e+06. What is the difference between the Aid flow from UN agencies (US$) in Sub-Saharan Africa (all income levels) in 1995 and the Aid flow from UN agencies (US$) in Sierra Leone in 1996?
Offer a very short reply. 1.67e+08. What is the difference between the Aid flow from UN agencies (US$) in Nicaragua in 1995 and the Aid flow from UN agencies (US$) in Sierra Leone in 1996?
Your response must be concise. -2.60e+05. What is the difference between the Aid flow from UN agencies (US$) in Europe(all income levels) in 1995 and the Aid flow from UN agencies (US$) in Sub-Saharan Africa (all income levels) in 1997?
Your response must be concise. -2.81e+08. What is the difference between the Aid flow from UN agencies (US$) in Europe(all income levels) in 1995 and the Aid flow from UN agencies (US$) in Sierra Leone in 1997?
Offer a very short reply. 9.74e+06. What is the difference between the Aid flow from UN agencies (US$) of Sub-Saharan Africa (all income levels) in 1995 and the Aid flow from UN agencies (US$) of Sierra Leone in 1997?
Provide a succinct answer. 1.71e+08. What is the difference between the Aid flow from UN agencies (US$) in Nicaragua in 1995 and the Aid flow from UN agencies (US$) in Sierra Leone in 1997?
Offer a very short reply. 3.87e+06. What is the difference between the Aid flow from UN agencies (US$) in Europe(all income levels) in 1996 and the Aid flow from UN agencies (US$) in Sub-Saharan Africa (all income levels) in 1997?
Ensure brevity in your answer.  -2.70e+08. What is the difference between the Aid flow from UN agencies (US$) in Sub-Saharan Africa (all income levels) in 1996 and the Aid flow from UN agencies (US$) in Sierra Leone in 1997?
Make the answer very short. 2.25e+08. What is the average Aid flow from UN agencies (US$) in Europe(all income levels) per year?
Make the answer very short. 1.28e+07. What is the average Aid flow from UN agencies (US$) of Sub-Saharan Africa (all income levels) per year?
Ensure brevity in your answer.  2.60e+08. What is the average Aid flow from UN agencies (US$) in Nicaragua per year?
Your response must be concise. 3.79e+06. What is the average Aid flow from UN agencies (US$) in Sierra Leone per year?
Give a very brief answer. 4.95e+06. In the year 1990, what is the difference between the Aid flow from UN agencies (US$) in Europe(all income levels) and Aid flow from UN agencies (US$) in Sub-Saharan Africa (all income levels)?
Offer a terse response. -2.98e+08. In the year 1990, what is the difference between the Aid flow from UN agencies (US$) in Europe(all income levels) and Aid flow from UN agencies (US$) in Nicaragua?
Ensure brevity in your answer.  7.13e+06. In the year 1990, what is the difference between the Aid flow from UN agencies (US$) of Europe(all income levels) and Aid flow from UN agencies (US$) of Sierra Leone?
Your answer should be compact. 4.90e+06. In the year 1990, what is the difference between the Aid flow from UN agencies (US$) of Sub-Saharan Africa (all income levels) and Aid flow from UN agencies (US$) of Nicaragua?
Keep it short and to the point. 3.05e+08. In the year 1990, what is the difference between the Aid flow from UN agencies (US$) in Sub-Saharan Africa (all income levels) and Aid flow from UN agencies (US$) in Sierra Leone?
Your response must be concise. 3.03e+08. In the year 1990, what is the difference between the Aid flow from UN agencies (US$) in Nicaragua and Aid flow from UN agencies (US$) in Sierra Leone?
Provide a succinct answer. -2.23e+06. In the year 1991, what is the difference between the Aid flow from UN agencies (US$) in Europe(all income levels) and Aid flow from UN agencies (US$) in Sub-Saharan Africa (all income levels)?
Your answer should be compact. -3.48e+08. In the year 1991, what is the difference between the Aid flow from UN agencies (US$) in Europe(all income levels) and Aid flow from UN agencies (US$) in Nicaragua?
Keep it short and to the point. 2.35e+06. In the year 1991, what is the difference between the Aid flow from UN agencies (US$) in Europe(all income levels) and Aid flow from UN agencies (US$) in Sierra Leone?
Offer a very short reply. 2.45e+06. In the year 1991, what is the difference between the Aid flow from UN agencies (US$) in Sub-Saharan Africa (all income levels) and Aid flow from UN agencies (US$) in Nicaragua?
Offer a very short reply. 3.51e+08. In the year 1991, what is the difference between the Aid flow from UN agencies (US$) of Sub-Saharan Africa (all income levels) and Aid flow from UN agencies (US$) of Sierra Leone?
Ensure brevity in your answer.  3.51e+08. In the year 1991, what is the difference between the Aid flow from UN agencies (US$) in Nicaragua and Aid flow from UN agencies (US$) in Sierra Leone?
Your answer should be very brief. 1.00e+05. In the year 1992, what is the difference between the Aid flow from UN agencies (US$) in Europe(all income levels) and Aid flow from UN agencies (US$) in Sub-Saharan Africa (all income levels)?
Keep it short and to the point. -2.90e+08. In the year 1992, what is the difference between the Aid flow from UN agencies (US$) of Europe(all income levels) and Aid flow from UN agencies (US$) of Nicaragua?
Keep it short and to the point. 4.00e+05. In the year 1992, what is the difference between the Aid flow from UN agencies (US$) in Europe(all income levels) and Aid flow from UN agencies (US$) in Sierra Leone?
Keep it short and to the point. 6.30e+05. In the year 1992, what is the difference between the Aid flow from UN agencies (US$) in Sub-Saharan Africa (all income levels) and Aid flow from UN agencies (US$) in Nicaragua?
Provide a succinct answer. 2.91e+08. In the year 1992, what is the difference between the Aid flow from UN agencies (US$) in Sub-Saharan Africa (all income levels) and Aid flow from UN agencies (US$) in Sierra Leone?
Give a very brief answer. 2.91e+08. In the year 1992, what is the difference between the Aid flow from UN agencies (US$) of Nicaragua and Aid flow from UN agencies (US$) of Sierra Leone?
Your response must be concise. 2.30e+05. In the year 1993, what is the difference between the Aid flow from UN agencies (US$) of Europe(all income levels) and Aid flow from UN agencies (US$) of Sub-Saharan Africa (all income levels)?
Your answer should be very brief. -2.33e+08. In the year 1993, what is the difference between the Aid flow from UN agencies (US$) in Europe(all income levels) and Aid flow from UN agencies (US$) in Nicaragua?
Your answer should be very brief. 1.08e+06. In the year 1993, what is the difference between the Aid flow from UN agencies (US$) in Europe(all income levels) and Aid flow from UN agencies (US$) in Sierra Leone?
Offer a very short reply. 1.90e+06. In the year 1993, what is the difference between the Aid flow from UN agencies (US$) of Sub-Saharan Africa (all income levels) and Aid flow from UN agencies (US$) of Nicaragua?
Give a very brief answer. 2.34e+08. In the year 1993, what is the difference between the Aid flow from UN agencies (US$) in Sub-Saharan Africa (all income levels) and Aid flow from UN agencies (US$) in Sierra Leone?
Your answer should be very brief. 2.35e+08. In the year 1993, what is the difference between the Aid flow from UN agencies (US$) in Nicaragua and Aid flow from UN agencies (US$) in Sierra Leone?
Your answer should be compact. 8.20e+05. In the year 1994, what is the difference between the Aid flow from UN agencies (US$) of Europe(all income levels) and Aid flow from UN agencies (US$) of Sub-Saharan Africa (all income levels)?
Keep it short and to the point. -1.80e+08. In the year 1994, what is the difference between the Aid flow from UN agencies (US$) of Europe(all income levels) and Aid flow from UN agencies (US$) of Nicaragua?
Offer a terse response. 1.65e+06. In the year 1994, what is the difference between the Aid flow from UN agencies (US$) in Europe(all income levels) and Aid flow from UN agencies (US$) in Sierra Leone?
Your response must be concise. 2.63e+06. In the year 1994, what is the difference between the Aid flow from UN agencies (US$) of Sub-Saharan Africa (all income levels) and Aid flow from UN agencies (US$) of Nicaragua?
Your response must be concise. 1.81e+08. In the year 1994, what is the difference between the Aid flow from UN agencies (US$) in Sub-Saharan Africa (all income levels) and Aid flow from UN agencies (US$) in Sierra Leone?
Ensure brevity in your answer.  1.82e+08. In the year 1994, what is the difference between the Aid flow from UN agencies (US$) in Nicaragua and Aid flow from UN agencies (US$) in Sierra Leone?
Give a very brief answer. 9.80e+05. In the year 1995, what is the difference between the Aid flow from UN agencies (US$) in Europe(all income levels) and Aid flow from UN agencies (US$) in Sub-Saharan Africa (all income levels)?
Your response must be concise. -1.61e+08. In the year 1995, what is the difference between the Aid flow from UN agencies (US$) in Europe(all income levels) and Aid flow from UN agencies (US$) in Nicaragua?
Give a very brief answer. 5.87e+06. In the year 1995, what is the difference between the Aid flow from UN agencies (US$) in Europe(all income levels) and Aid flow from UN agencies (US$) in Sierra Leone?
Offer a terse response. 7.11e+06. In the year 1995, what is the difference between the Aid flow from UN agencies (US$) of Sub-Saharan Africa (all income levels) and Aid flow from UN agencies (US$) of Nicaragua?
Your answer should be compact. 1.67e+08. In the year 1995, what is the difference between the Aid flow from UN agencies (US$) in Sub-Saharan Africa (all income levels) and Aid flow from UN agencies (US$) in Sierra Leone?
Provide a short and direct response. 1.68e+08. In the year 1995, what is the difference between the Aid flow from UN agencies (US$) in Nicaragua and Aid flow from UN agencies (US$) in Sierra Leone?
Make the answer very short. 1.24e+06. In the year 1996, what is the difference between the Aid flow from UN agencies (US$) in Europe(all income levels) and Aid flow from UN agencies (US$) in Sub-Saharan Africa (all income levels)?
Your response must be concise. -2.05e+08. In the year 1996, what is the difference between the Aid flow from UN agencies (US$) of Europe(all income levels) and Aid flow from UN agencies (US$) of Sierra Leone?
Give a very brief answer. 1.59e+07. In the year 1996, what is the difference between the Aid flow from UN agencies (US$) of Sub-Saharan Africa (all income levels) and Aid flow from UN agencies (US$) of Sierra Leone?
Make the answer very short. 2.21e+08. In the year 1997, what is the difference between the Aid flow from UN agencies (US$) of Europe(all income levels) and Aid flow from UN agencies (US$) of Sub-Saharan Africa (all income levels)?
Keep it short and to the point. -2.63e+08. In the year 1997, what is the difference between the Aid flow from UN agencies (US$) in Europe(all income levels) and Aid flow from UN agencies (US$) in Sierra Leone?
Your response must be concise. 2.74e+07. In the year 1997, what is the difference between the Aid flow from UN agencies (US$) of Sub-Saharan Africa (all income levels) and Aid flow from UN agencies (US$) of Sierra Leone?
Make the answer very short. 2.90e+08. What is the ratio of the Aid flow from UN agencies (US$) in Europe(all income levels) in 1990 to that in 1991?
Offer a terse response. 1.46. What is the ratio of the Aid flow from UN agencies (US$) in Sub-Saharan Africa (all income levels) in 1990 to that in 1991?
Make the answer very short. 0.87. What is the ratio of the Aid flow from UN agencies (US$) in Nicaragua in 1990 to that in 1991?
Provide a short and direct response. 0.57. What is the ratio of the Aid flow from UN agencies (US$) in Sierra Leone in 1990 to that in 1991?
Your answer should be compact. 1.13. What is the ratio of the Aid flow from UN agencies (US$) in Europe(all income levels) in 1990 to that in 1992?
Your answer should be compact. 2. What is the ratio of the Aid flow from UN agencies (US$) in Sub-Saharan Africa (all income levels) in 1990 to that in 1992?
Ensure brevity in your answer.  1.04. What is the ratio of the Aid flow from UN agencies (US$) in Nicaragua in 1990 to that in 1992?
Offer a terse response. 0.54. What is the ratio of the Aid flow from UN agencies (US$) of Sierra Leone in 1990 to that in 1992?
Offer a terse response. 1.11. What is the ratio of the Aid flow from UN agencies (US$) in Europe(all income levels) in 1990 to that in 1993?
Ensure brevity in your answer.  1.39. What is the ratio of the Aid flow from UN agencies (US$) in Sub-Saharan Africa (all income levels) in 1990 to that in 1993?
Your answer should be compact. 1.28. What is the ratio of the Aid flow from UN agencies (US$) of Nicaragua in 1990 to that in 1993?
Ensure brevity in your answer.  0.41. What is the ratio of the Aid flow from UN agencies (US$) in Sierra Leone in 1990 to that in 1993?
Give a very brief answer. 0.93. What is the ratio of the Aid flow from UN agencies (US$) in Europe(all income levels) in 1990 to that in 1994?
Offer a very short reply. 1.13. What is the ratio of the Aid flow from UN agencies (US$) in Sub-Saharan Africa (all income levels) in 1990 to that in 1994?
Provide a short and direct response. 1.64. What is the ratio of the Aid flow from UN agencies (US$) in Nicaragua in 1990 to that in 1994?
Ensure brevity in your answer.  0.35. What is the ratio of the Aid flow from UN agencies (US$) of Sierra Leone in 1990 to that in 1994?
Your response must be concise. 0.79. What is the ratio of the Aid flow from UN agencies (US$) of Europe(all income levels) in 1990 to that in 1995?
Keep it short and to the point. 0.73. What is the ratio of the Aid flow from UN agencies (US$) in Sub-Saharan Africa (all income levels) in 1990 to that in 1995?
Make the answer very short. 1.76. What is the ratio of the Aid flow from UN agencies (US$) in Nicaragua in 1990 to that in 1995?
Make the answer very short. 0.33. What is the ratio of the Aid flow from UN agencies (US$) in Sierra Leone in 1990 to that in 1995?
Keep it short and to the point. 0.79. What is the ratio of the Aid flow from UN agencies (US$) in Europe(all income levels) in 1990 to that in 1996?
Ensure brevity in your answer.  0.41. What is the ratio of the Aid flow from UN agencies (US$) in Sub-Saharan Africa (all income levels) in 1990 to that in 1996?
Offer a very short reply. 1.35. What is the ratio of the Aid flow from UN agencies (US$) of Sierra Leone in 1990 to that in 1996?
Keep it short and to the point. 0.63. What is the ratio of the Aid flow from UN agencies (US$) in Europe(all income levels) in 1990 to that in 1997?
Offer a terse response. 0.31. What is the ratio of the Aid flow from UN agencies (US$) in Sub-Saharan Africa (all income levels) in 1990 to that in 1997?
Offer a terse response. 1.05. What is the ratio of the Aid flow from UN agencies (US$) in Sierra Leone in 1990 to that in 1997?
Your answer should be very brief. 1.45. What is the ratio of the Aid flow from UN agencies (US$) of Europe(all income levels) in 1991 to that in 1992?
Give a very brief answer. 1.37. What is the ratio of the Aid flow from UN agencies (US$) in Sub-Saharan Africa (all income levels) in 1991 to that in 1992?
Your answer should be very brief. 1.2. What is the ratio of the Aid flow from UN agencies (US$) in Nicaragua in 1991 to that in 1992?
Your response must be concise. 0.95. What is the ratio of the Aid flow from UN agencies (US$) of Europe(all income levels) in 1991 to that in 1993?
Provide a succinct answer. 0.95. What is the ratio of the Aid flow from UN agencies (US$) in Sub-Saharan Africa (all income levels) in 1991 to that in 1993?
Offer a very short reply. 1.48. What is the ratio of the Aid flow from UN agencies (US$) in Nicaragua in 1991 to that in 1993?
Keep it short and to the point. 0.72. What is the ratio of the Aid flow from UN agencies (US$) in Sierra Leone in 1991 to that in 1993?
Make the answer very short. 0.82. What is the ratio of the Aid flow from UN agencies (US$) of Europe(all income levels) in 1991 to that in 1994?
Offer a very short reply. 0.77. What is the ratio of the Aid flow from UN agencies (US$) in Sub-Saharan Africa (all income levels) in 1991 to that in 1994?
Ensure brevity in your answer.  1.89. What is the ratio of the Aid flow from UN agencies (US$) in Nicaragua in 1991 to that in 1994?
Provide a succinct answer. 0.62. What is the ratio of the Aid flow from UN agencies (US$) in Sierra Leone in 1991 to that in 1994?
Give a very brief answer. 0.7. What is the ratio of the Aid flow from UN agencies (US$) in Europe(all income levels) in 1991 to that in 1995?
Ensure brevity in your answer.  0.5. What is the ratio of the Aid flow from UN agencies (US$) in Sub-Saharan Africa (all income levels) in 1991 to that in 1995?
Offer a very short reply. 2.04. What is the ratio of the Aid flow from UN agencies (US$) of Nicaragua in 1991 to that in 1995?
Your answer should be very brief. 0.59. What is the ratio of the Aid flow from UN agencies (US$) of Sierra Leone in 1991 to that in 1995?
Offer a very short reply. 0.7. What is the ratio of the Aid flow from UN agencies (US$) in Europe(all income levels) in 1991 to that in 1996?
Offer a very short reply. 0.28. What is the ratio of the Aid flow from UN agencies (US$) in Sub-Saharan Africa (all income levels) in 1991 to that in 1996?
Provide a succinct answer. 1.55. What is the ratio of the Aid flow from UN agencies (US$) of Sierra Leone in 1991 to that in 1996?
Ensure brevity in your answer.  0.55. What is the ratio of the Aid flow from UN agencies (US$) of Europe(all income levels) in 1991 to that in 1997?
Your answer should be very brief. 0.21. What is the ratio of the Aid flow from UN agencies (US$) of Sub-Saharan Africa (all income levels) in 1991 to that in 1997?
Your response must be concise. 1.21. What is the ratio of the Aid flow from UN agencies (US$) in Sierra Leone in 1991 to that in 1997?
Offer a terse response. 1.28. What is the ratio of the Aid flow from UN agencies (US$) of Europe(all income levels) in 1992 to that in 1993?
Your response must be concise. 0.69. What is the ratio of the Aid flow from UN agencies (US$) of Sub-Saharan Africa (all income levels) in 1992 to that in 1993?
Make the answer very short. 1.23. What is the ratio of the Aid flow from UN agencies (US$) of Nicaragua in 1992 to that in 1993?
Your response must be concise. 0.75. What is the ratio of the Aid flow from UN agencies (US$) of Sierra Leone in 1992 to that in 1993?
Your answer should be very brief. 0.83. What is the ratio of the Aid flow from UN agencies (US$) in Europe(all income levels) in 1992 to that in 1994?
Offer a very short reply. 0.57. What is the ratio of the Aid flow from UN agencies (US$) of Sub-Saharan Africa (all income levels) in 1992 to that in 1994?
Provide a succinct answer. 1.57. What is the ratio of the Aid flow from UN agencies (US$) in Nicaragua in 1992 to that in 1994?
Offer a terse response. 0.64. What is the ratio of the Aid flow from UN agencies (US$) of Sierra Leone in 1992 to that in 1994?
Give a very brief answer. 0.71. What is the ratio of the Aid flow from UN agencies (US$) in Europe(all income levels) in 1992 to that in 1995?
Provide a succinct answer. 0.37. What is the ratio of the Aid flow from UN agencies (US$) of Sub-Saharan Africa (all income levels) in 1992 to that in 1995?
Offer a very short reply. 1.69. What is the ratio of the Aid flow from UN agencies (US$) in Nicaragua in 1992 to that in 1995?
Provide a succinct answer. 0.62. What is the ratio of the Aid flow from UN agencies (US$) in Sierra Leone in 1992 to that in 1995?
Keep it short and to the point. 0.71. What is the ratio of the Aid flow from UN agencies (US$) in Europe(all income levels) in 1992 to that in 1996?
Make the answer very short. 0.2. What is the ratio of the Aid flow from UN agencies (US$) of Sub-Saharan Africa (all income levels) in 1992 to that in 1996?
Your response must be concise. 1.29. What is the ratio of the Aid flow from UN agencies (US$) in Sierra Leone in 1992 to that in 1996?
Provide a succinct answer. 0.56. What is the ratio of the Aid flow from UN agencies (US$) in Europe(all income levels) in 1992 to that in 1997?
Your answer should be very brief. 0.16. What is the ratio of the Aid flow from UN agencies (US$) of Sub-Saharan Africa (all income levels) in 1992 to that in 1997?
Keep it short and to the point. 1.01. What is the ratio of the Aid flow from UN agencies (US$) in Sierra Leone in 1992 to that in 1997?
Provide a succinct answer. 1.3. What is the ratio of the Aid flow from UN agencies (US$) in Europe(all income levels) in 1993 to that in 1994?
Offer a very short reply. 0.81. What is the ratio of the Aid flow from UN agencies (US$) in Sub-Saharan Africa (all income levels) in 1993 to that in 1994?
Ensure brevity in your answer.  1.28. What is the ratio of the Aid flow from UN agencies (US$) in Nicaragua in 1993 to that in 1994?
Offer a very short reply. 0.85. What is the ratio of the Aid flow from UN agencies (US$) of Sierra Leone in 1993 to that in 1994?
Provide a short and direct response. 0.86. What is the ratio of the Aid flow from UN agencies (US$) of Europe(all income levels) in 1993 to that in 1995?
Offer a terse response. 0.53. What is the ratio of the Aid flow from UN agencies (US$) in Sub-Saharan Africa (all income levels) in 1993 to that in 1995?
Your answer should be compact. 1.38. What is the ratio of the Aid flow from UN agencies (US$) of Nicaragua in 1993 to that in 1995?
Provide a succinct answer. 0.82. What is the ratio of the Aid flow from UN agencies (US$) in Sierra Leone in 1993 to that in 1995?
Offer a terse response. 0.85. What is the ratio of the Aid flow from UN agencies (US$) in Europe(all income levels) in 1993 to that in 1996?
Make the answer very short. 0.29. What is the ratio of the Aid flow from UN agencies (US$) of Sub-Saharan Africa (all income levels) in 1993 to that in 1996?
Your answer should be compact. 1.05. What is the ratio of the Aid flow from UN agencies (US$) of Sierra Leone in 1993 to that in 1996?
Give a very brief answer. 0.68. What is the ratio of the Aid flow from UN agencies (US$) of Europe(all income levels) in 1993 to that in 1997?
Ensure brevity in your answer.  0.22. What is the ratio of the Aid flow from UN agencies (US$) in Sub-Saharan Africa (all income levels) in 1993 to that in 1997?
Provide a succinct answer. 0.82. What is the ratio of the Aid flow from UN agencies (US$) of Sierra Leone in 1993 to that in 1997?
Your response must be concise. 1.57. What is the ratio of the Aid flow from UN agencies (US$) in Europe(all income levels) in 1994 to that in 1995?
Your response must be concise. 0.65. What is the ratio of the Aid flow from UN agencies (US$) in Sub-Saharan Africa (all income levels) in 1994 to that in 1995?
Make the answer very short. 1.08. What is the ratio of the Aid flow from UN agencies (US$) in Nicaragua in 1994 to that in 1995?
Offer a very short reply. 0.96. What is the ratio of the Aid flow from UN agencies (US$) in Sierra Leone in 1994 to that in 1995?
Offer a very short reply. 0.99. What is the ratio of the Aid flow from UN agencies (US$) in Europe(all income levels) in 1994 to that in 1996?
Offer a terse response. 0.36. What is the ratio of the Aid flow from UN agencies (US$) of Sub-Saharan Africa (all income levels) in 1994 to that in 1996?
Your answer should be compact. 0.82. What is the ratio of the Aid flow from UN agencies (US$) of Sierra Leone in 1994 to that in 1996?
Your response must be concise. 0.79. What is the ratio of the Aid flow from UN agencies (US$) of Europe(all income levels) in 1994 to that in 1997?
Keep it short and to the point. 0.27. What is the ratio of the Aid flow from UN agencies (US$) of Sub-Saharan Africa (all income levels) in 1994 to that in 1997?
Your answer should be very brief. 0.64. What is the ratio of the Aid flow from UN agencies (US$) in Sierra Leone in 1994 to that in 1997?
Provide a short and direct response. 1.83. What is the ratio of the Aid flow from UN agencies (US$) in Europe(all income levels) in 1995 to that in 1996?
Make the answer very short. 0.56. What is the ratio of the Aid flow from UN agencies (US$) in Sub-Saharan Africa (all income levels) in 1995 to that in 1996?
Make the answer very short. 0.76. What is the ratio of the Aid flow from UN agencies (US$) of Sierra Leone in 1995 to that in 1996?
Provide a succinct answer. 0.79. What is the ratio of the Aid flow from UN agencies (US$) in Europe(all income levels) in 1995 to that in 1997?
Keep it short and to the point. 0.42. What is the ratio of the Aid flow from UN agencies (US$) in Sub-Saharan Africa (all income levels) in 1995 to that in 1997?
Provide a short and direct response. 0.59. What is the ratio of the Aid flow from UN agencies (US$) of Sierra Leone in 1995 to that in 1997?
Your response must be concise. 1.83. What is the ratio of the Aid flow from UN agencies (US$) of Europe(all income levels) in 1996 to that in 1997?
Your answer should be very brief. 0.76. What is the ratio of the Aid flow from UN agencies (US$) of Sub-Saharan Africa (all income levels) in 1996 to that in 1997?
Your answer should be compact. 0.78. What is the ratio of the Aid flow from UN agencies (US$) in Sierra Leone in 1996 to that in 1997?
Your answer should be compact. 2.31. What is the difference between the highest and the second highest Aid flow from UN agencies (US$) in Europe(all income levels)?
Give a very brief answer. 7.35e+06. What is the difference between the highest and the second highest Aid flow from UN agencies (US$) in Sub-Saharan Africa (all income levels)?
Ensure brevity in your answer.  4.74e+07. What is the difference between the highest and the second highest Aid flow from UN agencies (US$) of Nicaragua?
Make the answer very short. 2.90e+05. What is the difference between the highest and the second highest Aid flow from UN agencies (US$) of Sierra Leone?
Provide a succinct answer. 1.50e+06. What is the difference between the highest and the lowest Aid flow from UN agencies (US$) in Europe(all income levels)?
Provide a short and direct response. 2.58e+07. What is the difference between the highest and the lowest Aid flow from UN agencies (US$) of Sub-Saharan Africa (all income levels)?
Your answer should be compact. 1.81e+08. What is the difference between the highest and the lowest Aid flow from UN agencies (US$) in Nicaragua?
Your answer should be very brief. 7.02e+06. What is the difference between the highest and the lowest Aid flow from UN agencies (US$) in Sierra Leone?
Make the answer very short. 4.13e+06. 